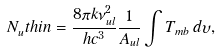<formula> <loc_0><loc_0><loc_500><loc_500>N _ { u } ^ { \, } t h i n = \frac { 8 \pi k \nu _ { u l } ^ { 2 } } { h c ^ { 3 } } \frac { 1 } { A _ { u l } } \int { T _ { m b } } \, d \upsilon ,</formula> 